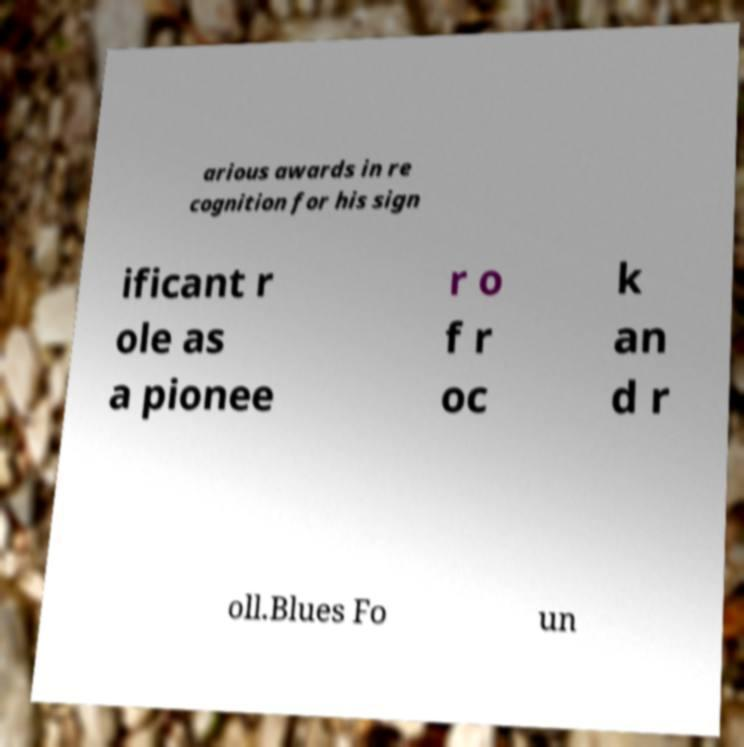Please read and relay the text visible in this image. What does it say? arious awards in re cognition for his sign ificant r ole as a pionee r o f r oc k an d r oll.Blues Fo un 